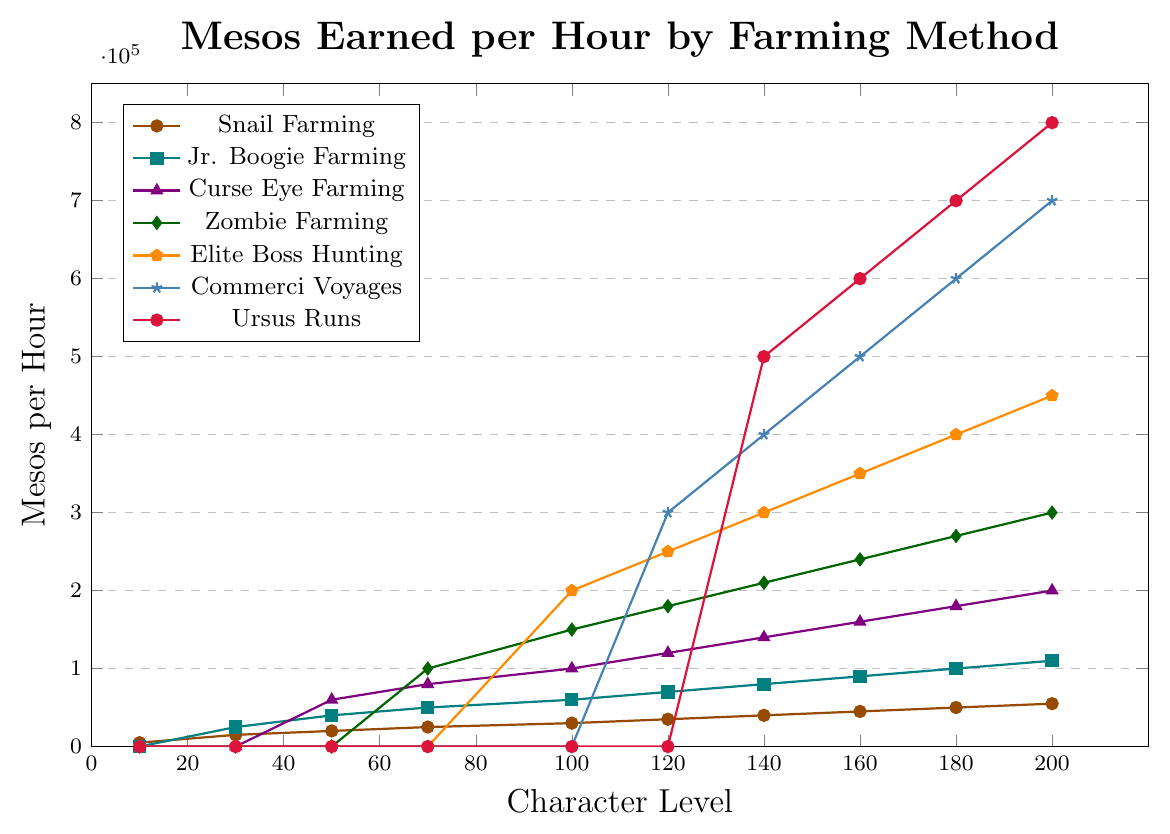What is the highest Mesos per hour earned using Jr. Boogie Farming between levels 100 and 200? Examine the plot line for Jr. Boogie Farming (colored in teal). The Mesos per hour gradually increase from 60,000 at level 100 to 110,000 at level 200. The highest value within this range is 110,000 at level 200.
Answer: 110,000 Which farming method yields the highest Mesos per hour at level 160? Compare the y-values for all farming methods at level 160. Ursus Runs (colored in red) yield the highest, with 600,000 Mesos per hour.
Answer: Ursus Runs How much more Mesos per hour does Elite Boss Hunting yield than Zombie Farming at level 140? Find the Mesos per hour for both Elite Boss Hunting (orange) and Zombie Farming (green) at level 140. Elite Boss Hunting yields 300,000 Mesos, while Zombie Farming yields 210,000 Mesos. The difference is 300,000 - 210,000 = 90,000.
Answer: 90,000 Which method starts to contribute to the Mesos per hour at level 120? Identify the method lines that begin non-zero values at level 120. Commerci Voyages (blue) starts at level 120.
Answer: Commerci Voyages What is the trend in Mesos earned per hour by Snail Farming from level 10 to level 200? Follow the plot line for Snail Farming (brown). It shows a steady increasing trend starting from 5,000 at level 10 up to 55,000 at level 200.
Answer: Increasing What is the combined Mesos per hour from Zombie Farming and Curse Eye Farming at level 180? Look at the values for both Zombie Farming (green) and Curse Eye Farming (purple) at level 180. Zombie Farming earns 270,000 Mesos per hour, and Curse Eye Farming earns 180,000 Mesos per hour. Their sum is 270,000 + 180,000 = 450,000.
Answer: 450,000 Which farming method shows the largest increase in Mesos per hour between level 120 and level 140? Evaluate the differences in Mesos per hour between levels 120 and 140 for each method. Ursus Runs increase from 0 to 500,000, which is the largest increase of 500,000 Mesos per hour.
Answer: Ursus Runs At what level does Elite Boss Hunting start to yield Mesos per hour? Identify the level at which Elite Boss Hunting (orange) begins to show a non-zero value. The plot line starts at level 100.
Answer: 100 Which farming method yields an equal amount of Mesos per hour at level 120 and level 160? Observe all plot lines at levels 120 and 160. Jr. Boogie Farming (teal) yields 70,000 Mesos per hour at both levels.
Answer: Jr. Boogie Farming How does the Mesos per hour earned from Commerci Voyages change from level 140 to level 180? Observe the difference in the plot line for Commerci Voyages (blue) from level 140 to level 180. The Mesos per hour increase from 400,000 at level 140 to 600,000 at level 180.
Answer: Increase 